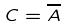Convert formula to latex. <formula><loc_0><loc_0><loc_500><loc_500>C = \overline { A }</formula> 